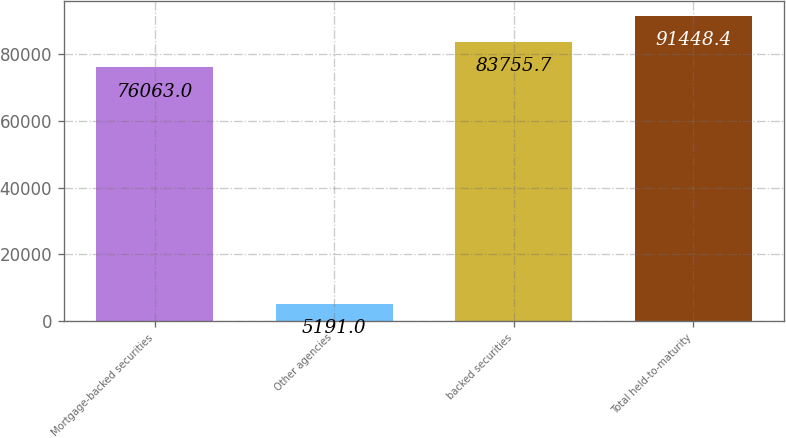Convert chart. <chart><loc_0><loc_0><loc_500><loc_500><bar_chart><fcel>Mortgage-backed securities<fcel>Other agencies<fcel>backed securities<fcel>Total held-to-maturity<nl><fcel>76063<fcel>5191<fcel>83755.7<fcel>91448.4<nl></chart> 